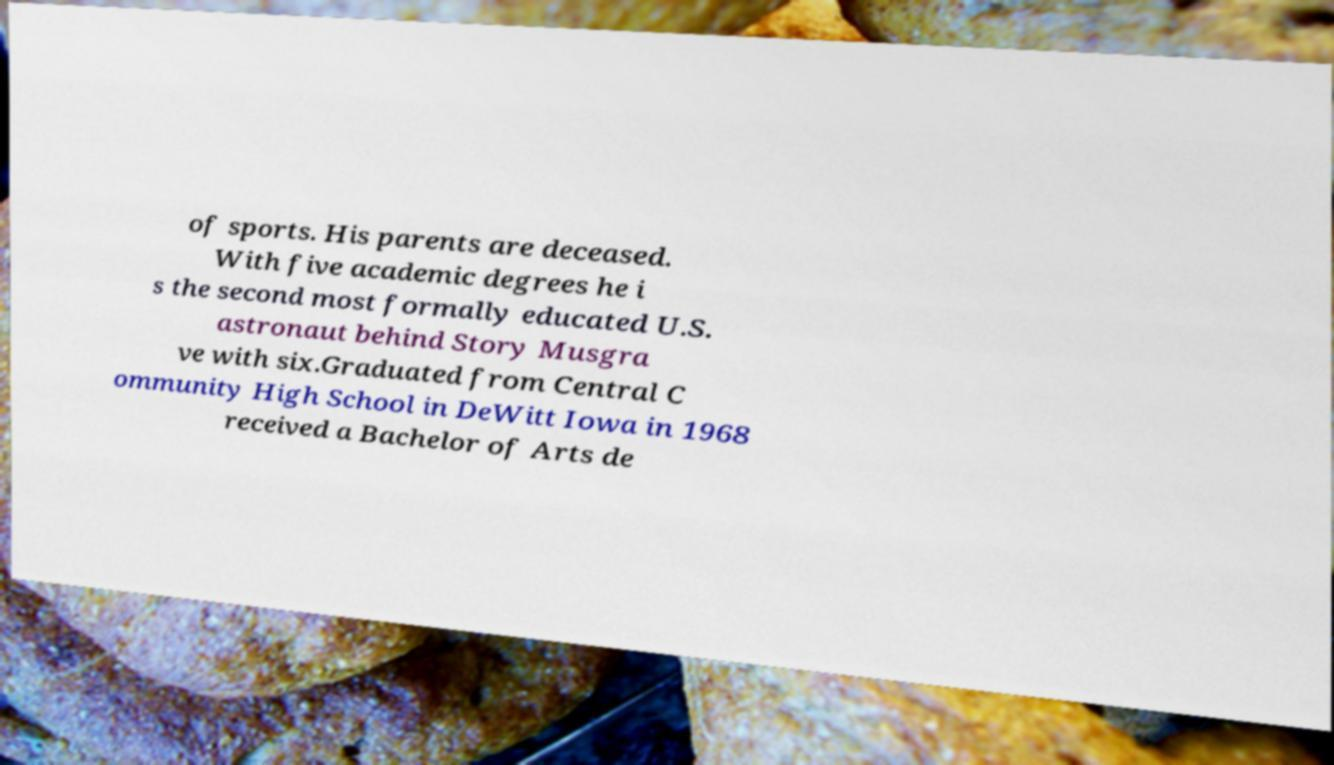Could you assist in decoding the text presented in this image and type it out clearly? of sports. His parents are deceased. With five academic degrees he i s the second most formally educated U.S. astronaut behind Story Musgra ve with six.Graduated from Central C ommunity High School in DeWitt Iowa in 1968 received a Bachelor of Arts de 